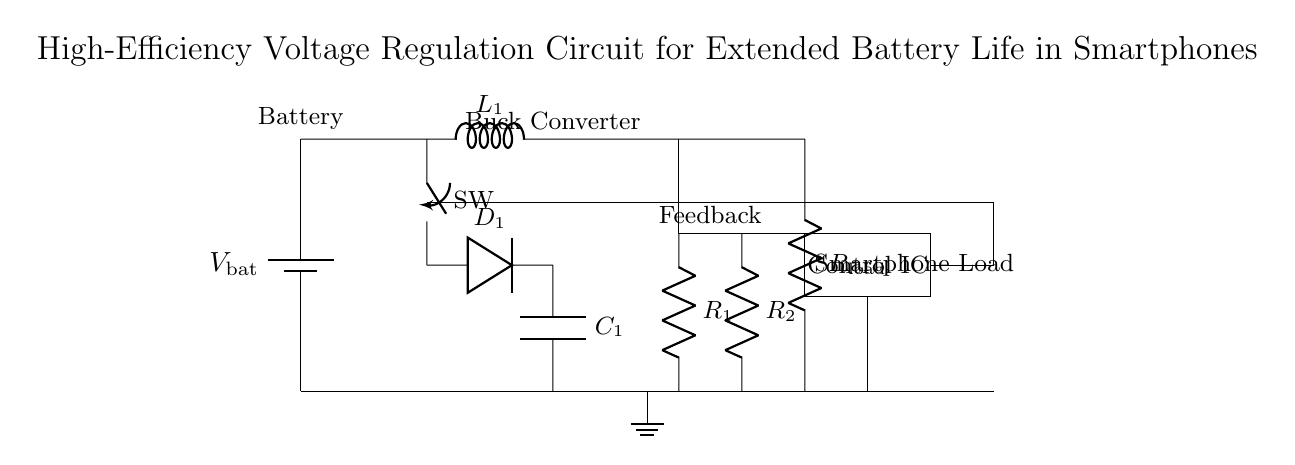What is the main component used for voltage regulation in this circuit? The main component for voltage regulation in this circuit is the buck converter, which is designed to step down the voltage efficiently.
Answer: Buck converter What is the function of the switch labeled SW? The switch labeled SW controls the connection between the input voltage and the buck converter, allowing or interrupting the flow of current as needed for regulation.
Answer: Control current flow What type of load is represented by R load? R load represents the smartphone's electrical components that require power, functioning as the device load in this regulation circuit.
Answer: Smartphone Load What role does the control IC play in this circuit? The control IC manages the operation of the buck converter, including adjusting the duty cycle based on feedback for optimal voltage output and efficiency.
Answer: Manages voltage output How are the resistors R1 and R2 used in this circuit? R1 and R2 are part of the feedback network that helps the control IC determine the output voltage level, aiding in voltage regulation by comparing the output voltage to the desired level.
Answer: Feedback voltage sensing What is the purpose of the inductor L1 in the buck converter? The inductor L1 stores energy when the switch is closed and releases it to the load when the switch is open, smoothing out the output voltage and contributing to the efficiency of the voltage regulation.
Answer: Energy storage and smoothing What is the primary benefit of using this high-efficiency voltage regulation circuit in smartphones? The primary benefit is extended battery life; by efficiently stepping down voltage, the circuit reduces power loss and maximizes the energy delivered to the load.
Answer: Extended battery life 